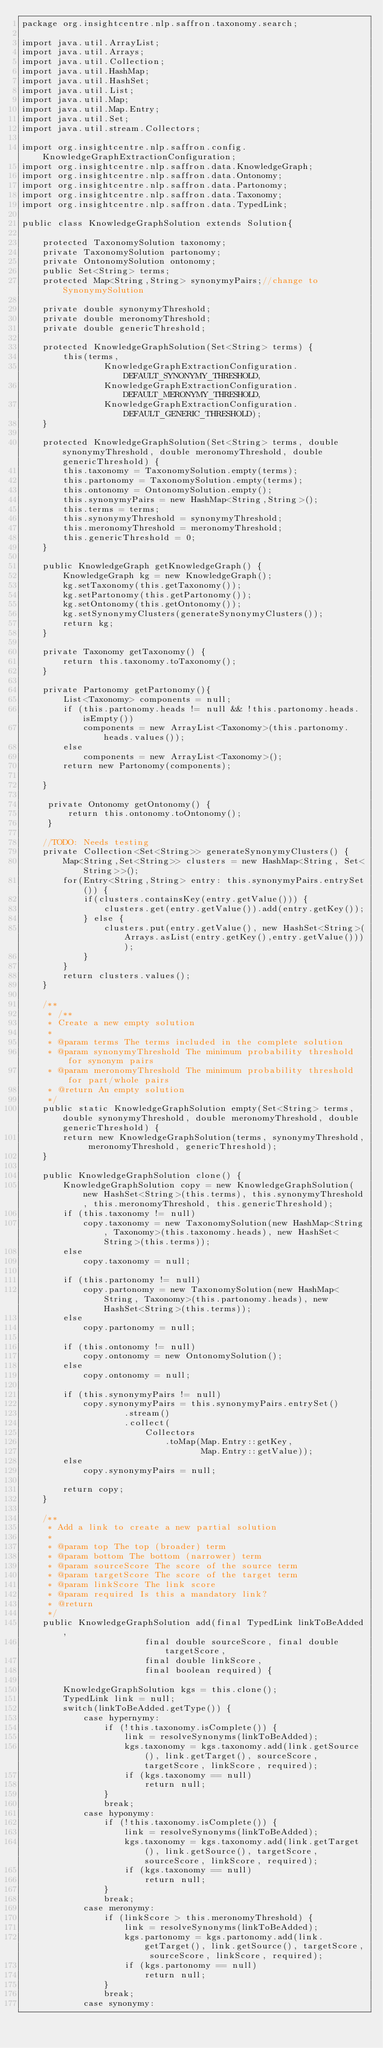<code> <loc_0><loc_0><loc_500><loc_500><_Java_>package org.insightcentre.nlp.saffron.taxonomy.search;

import java.util.ArrayList;
import java.util.Arrays;
import java.util.Collection;
import java.util.HashMap;
import java.util.HashSet;
import java.util.List;
import java.util.Map;
import java.util.Map.Entry;
import java.util.Set;
import java.util.stream.Collectors;

import org.insightcentre.nlp.saffron.config.KnowledgeGraphExtractionConfiguration;
import org.insightcentre.nlp.saffron.data.KnowledgeGraph;
import org.insightcentre.nlp.saffron.data.Ontonomy;
import org.insightcentre.nlp.saffron.data.Partonomy;
import org.insightcentre.nlp.saffron.data.Taxonomy;
import org.insightcentre.nlp.saffron.data.TypedLink;

public class KnowledgeGraphSolution extends Solution{

	protected TaxonomySolution taxonomy;
	private TaxonomySolution partonomy;
	private OntonomySolution ontonomy;
    public Set<String> terms;
    protected Map<String,String> synonymyPairs;//change to SynonymySolution

    private double synonymyThreshold;
    private double meronomyThreshold;
    private double genericThreshold;

    protected KnowledgeGraphSolution(Set<String> terms) {
        this(terms,
        		KnowledgeGraphExtractionConfiguration.DEFAULT_SYNONYMY_THRESHOLD,
        		KnowledgeGraphExtractionConfiguration.DEFAULT_MERONYMY_THRESHOLD,
        		KnowledgeGraphExtractionConfiguration.DEFAULT_GENERIC_THRESHOLD);
    }
    
    protected KnowledgeGraphSolution(Set<String> terms, double synonymyThreshold, double meronomyThreshold, double genericThreshold) {
    	this.taxonomy = TaxonomySolution.empty(terms);
        this.partonomy = TaxonomySolution.empty(terms);
        this.ontonomy = OntonomySolution.empty();
        this.synonymyPairs = new HashMap<String,String>();
        this.terms = terms;
        this.synonymyThreshold = synonymyThreshold;
        this.meronomyThreshold = meronomyThreshold;
        this.genericThreshold = 0;
    }

    public KnowledgeGraph getKnowledgeGraph() {
    	KnowledgeGraph kg = new KnowledgeGraph();
    	kg.setTaxonomy(this.getTaxonomy());
    	kg.setPartonomy(this.getPartonomy());
    	kg.setOntonomy(this.getOntonomy());
    	kg.setSynonymyClusters(generateSynonymyClusters());
    	return kg;
    }
    
    private Taxonomy getTaxonomy() {
    	return this.taxonomy.toTaxonomy();
    }
    
    private Partonomy getPartonomy(){
    	List<Taxonomy> components = null;
    	if (this.partonomy.heads != null && !this.partonomy.heads.isEmpty())
    		components = new ArrayList<Taxonomy>(this.partonomy.heads.values());
    	else
    		components = new ArrayList<Taxonomy>();
		return new Partonomy(components); 
    	
    }

     private Ontonomy getOntonomy() {
    	 return this.ontonomy.toOntonomy();
     }

    //TODO: Needs testing
    private Collection<Set<String>> generateSynonymyClusters() {
    	Map<String,Set<String>> clusters = new HashMap<String, Set<String>>();
    	for(Entry<String,String> entry: this.synonymyPairs.entrySet()) {
    		if(clusters.containsKey(entry.getValue())) {
    			clusters.get(entry.getValue()).add(entry.getKey());
    		} else {
    			clusters.put(entry.getValue(), new HashSet<String>(Arrays.asList(entry.getKey(),entry.getValue())));
    		}
    	}
    	return clusters.values();
    }
    
	/**
	 * /**
     * Create a new empty solution
     *
     * @param terms The terms included in the complete solution
     * @param synonymyThreshold The minimum probability threshold for synonym pairs
	 * @param meronomyThreshold The minimum probability threshold for part/whole pairs
     * @return An empty solution
	 */
    public static KnowledgeGraphSolution empty(Set<String> terms, double synonymyThreshold, double meronomyThreshold, double genericThreshold) {
        return new KnowledgeGraphSolution(terms, synonymyThreshold, meronomyThreshold, genericThreshold);
    }
    
    public KnowledgeGraphSolution clone() {
    	KnowledgeGraphSolution copy = new KnowledgeGraphSolution(new HashSet<String>(this.terms), this.synonymyThreshold, this.meronomyThreshold, this.genericThreshold);
    	if (this.taxonomy != null) 
    		copy.taxonomy = new TaxonomySolution(new HashMap<String, Taxonomy>(this.taxonomy.heads), new HashSet<String>(this.terms));
    	else
    		copy.taxonomy = null;
    	
    	if (this.partonomy != null)
    		copy.partonomy = new TaxonomySolution(new HashMap<String, Taxonomy>(this.partonomy.heads), new HashSet<String>(this.terms));
    	else
    		copy.partonomy = null;
    	
    	if (this.ontonomy != null)
    		copy.ontonomy = new OntonomySolution();
    	else
    		copy.ontonomy = null;

    	if (this.synonymyPairs != null)
    		copy.synonymyPairs = this.synonymyPairs.entrySet() 
                    .stream() 
                    .collect( 
                        Collectors 
                            .toMap(Map.Entry::getKey, 
                                   Map.Entry::getValue));
    	else
    		copy.synonymyPairs = null;
    	
    	return copy;
    }
    
    /**
     * Add a link to create a new partial solution
     *
     * @param top The top (broader) term
     * @param bottom The bottom (narrower) term
     * @param sourceScore The score of the source term
     * @param targetScore The score of the target term
     * @param linkScore The link score
     * @param required Is this a mandatory link?
     * @return
     */
    public KnowledgeGraphSolution add(final TypedLink linkToBeAdded,
                        final double sourceScore, final double targetScore,
                        final double linkScore,
                        final boolean required) {
    	
    	KnowledgeGraphSolution kgs = this.clone();
    	TypedLink link = null;
    	switch(linkToBeAdded.getType()) {
	    	case hypernymy:
	    		if (!this.taxonomy.isComplete()) {
		    		link = resolveSynonyms(linkToBeAdded);
		    		kgs.taxonomy = kgs.taxonomy.add(link.getSource(), link.getTarget(), sourceScore, targetScore, linkScore, required);
		    		if (kgs.taxonomy == null)
		    			return null;
	    		}
	    		break;
	    	case hyponymy:
	    		if (!this.taxonomy.isComplete()) {
		    		link = resolveSynonyms(linkToBeAdded);
		    		kgs.taxonomy = kgs.taxonomy.add(link.getTarget(), link.getSource(), targetScore, sourceScore, linkScore, required);
		    		if (kgs.taxonomy == null)
		    			return null;
	    		}
	    		break;
	    	case meronymy:
	    		if (linkScore > this.meronomyThreshold) {
		    		link = resolveSynonyms(linkToBeAdded);
		    		kgs.partonomy = kgs.partonomy.add(link.getTarget(), link.getSource(), targetScore, sourceScore, linkScore, required);
		    		if (kgs.partonomy == null)
		    			return null;
	    		}
		    	break;
	    	case synonymy:</code> 